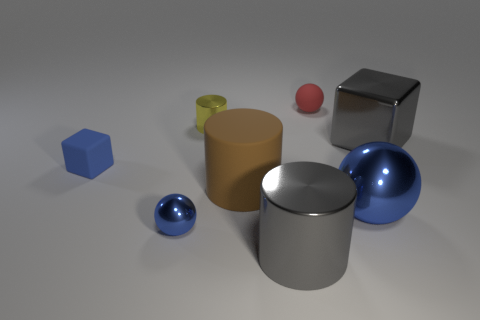Is there any object that appears farther from the viewer than the red sphere? Judging by the composition of the image, the small yellow object directly behind the red sphere is at a slightly further distance from the viewer's perspective. Its smaller size and relative positioning to the red sphere within the three-dimensional scene suggest increased depth. Can you estimate the size of the objects in relation to each other? Estimates of relative size can be made from visual assessment. The red sphere and the yellow cylinder appear to be the smallest, followed by the blue hexahedron. The silver cylindrical object and the sphere beside it are larger, while the silver cube appears as the largest object in the scene. 